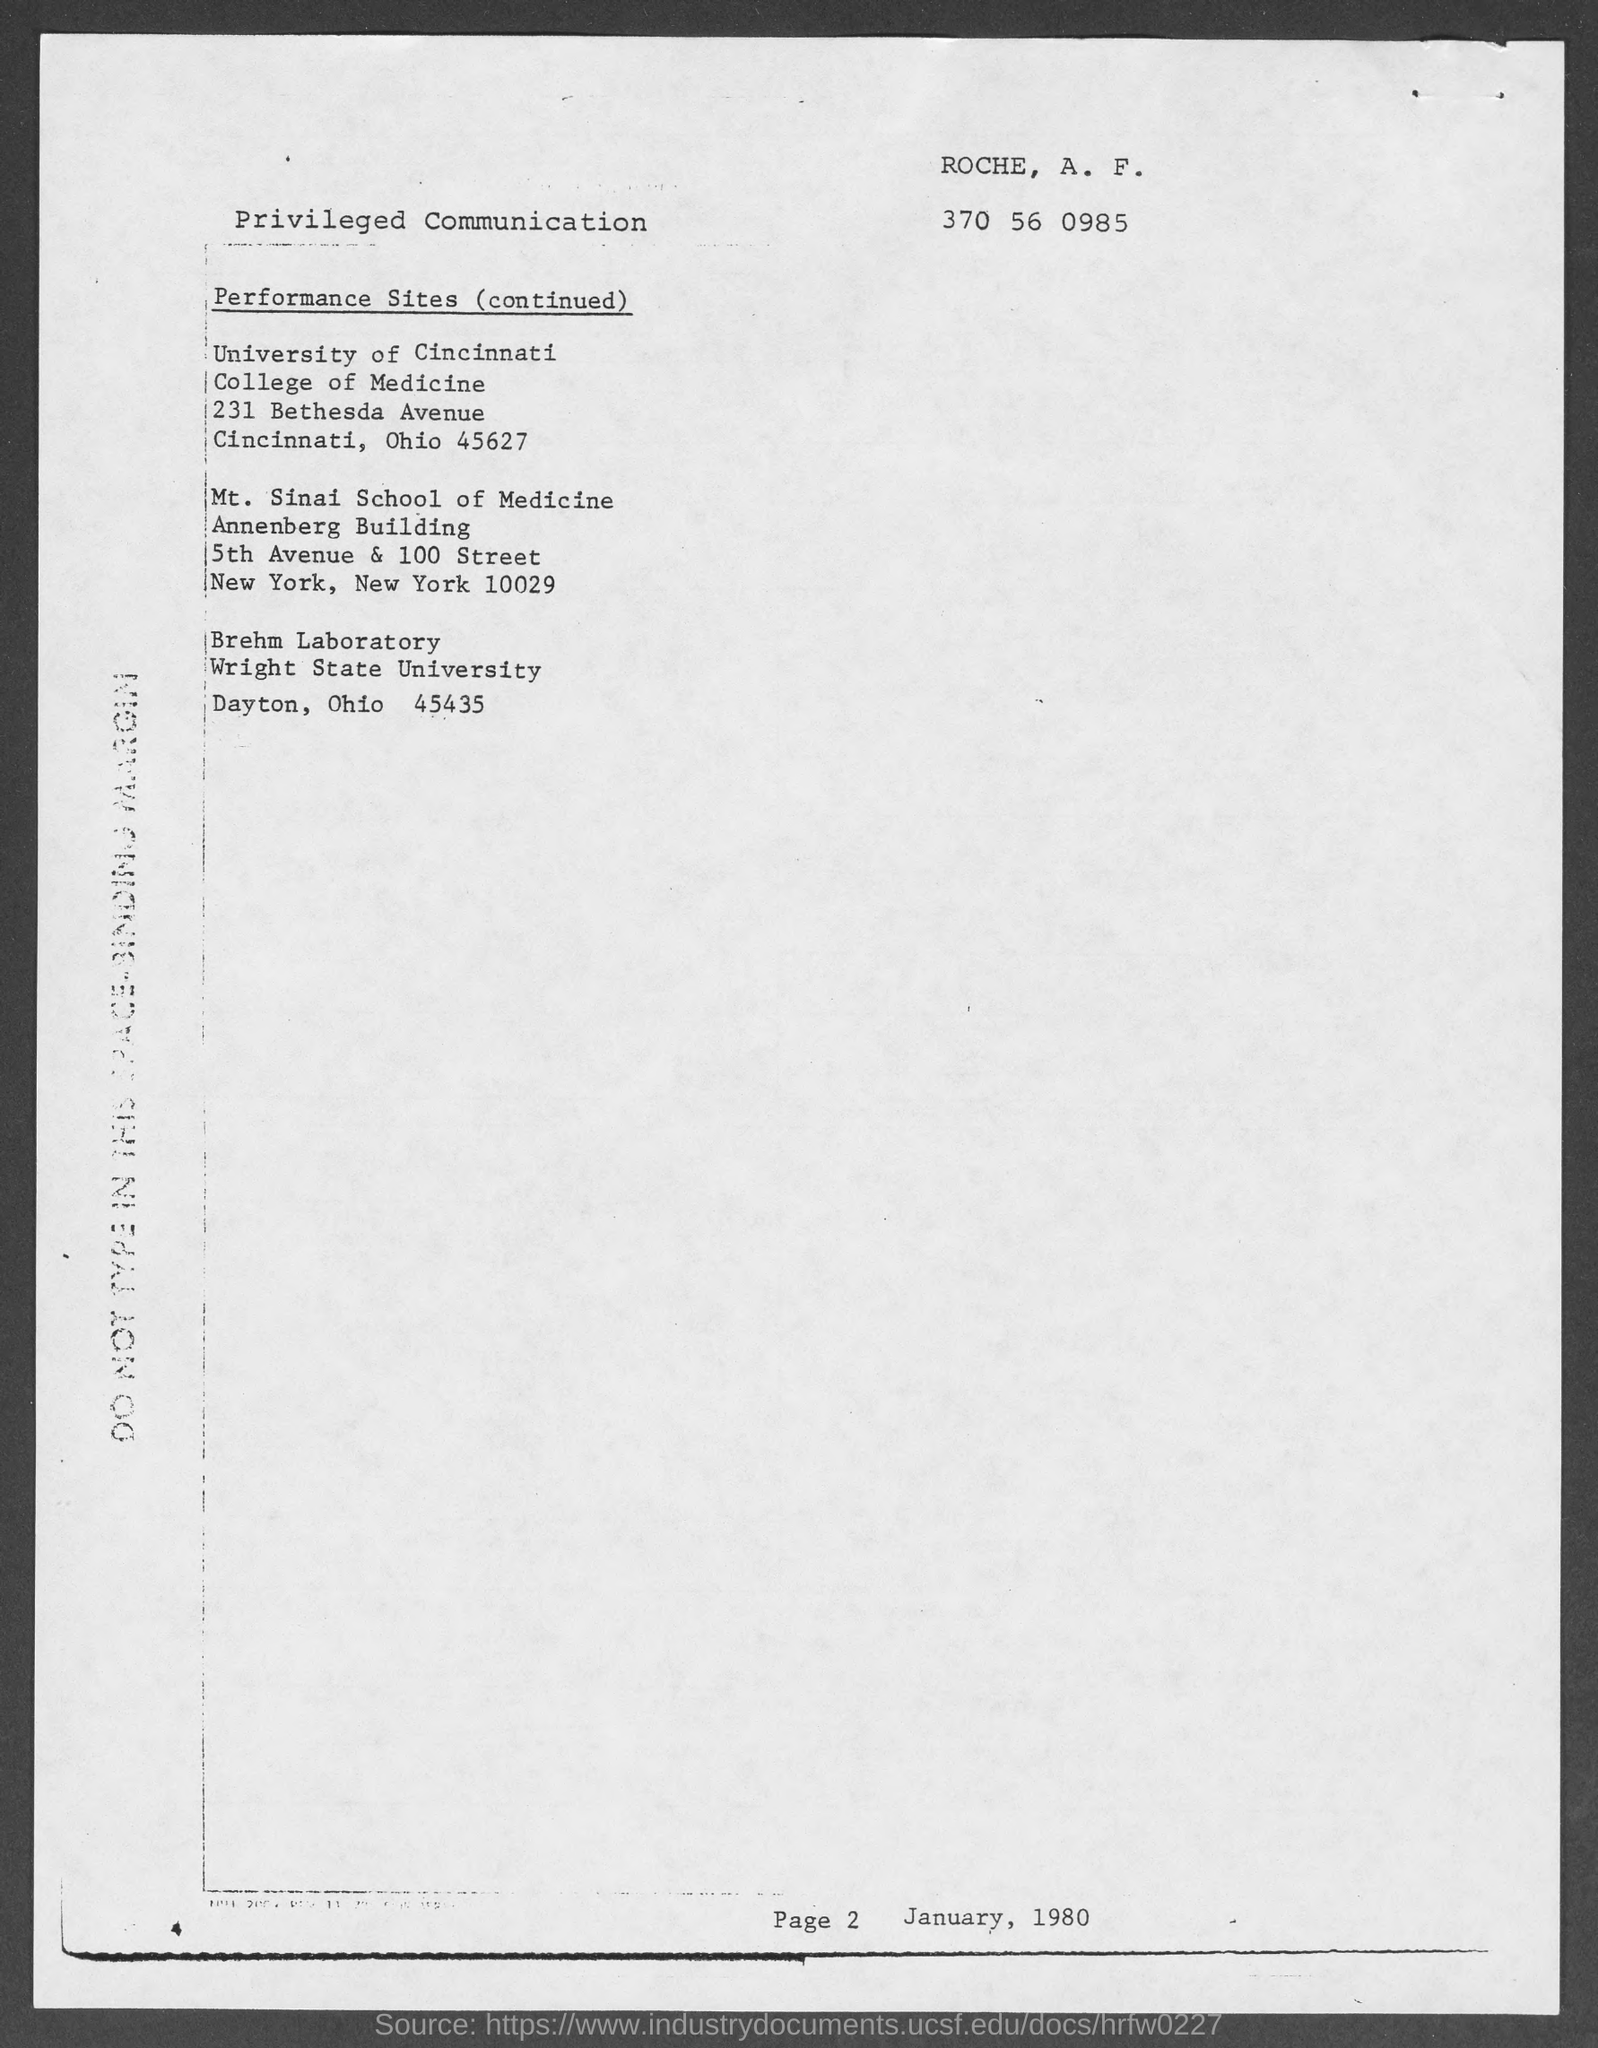In which building Mt. Sinai School of medicine
Give a very brief answer. Annenberg building. 